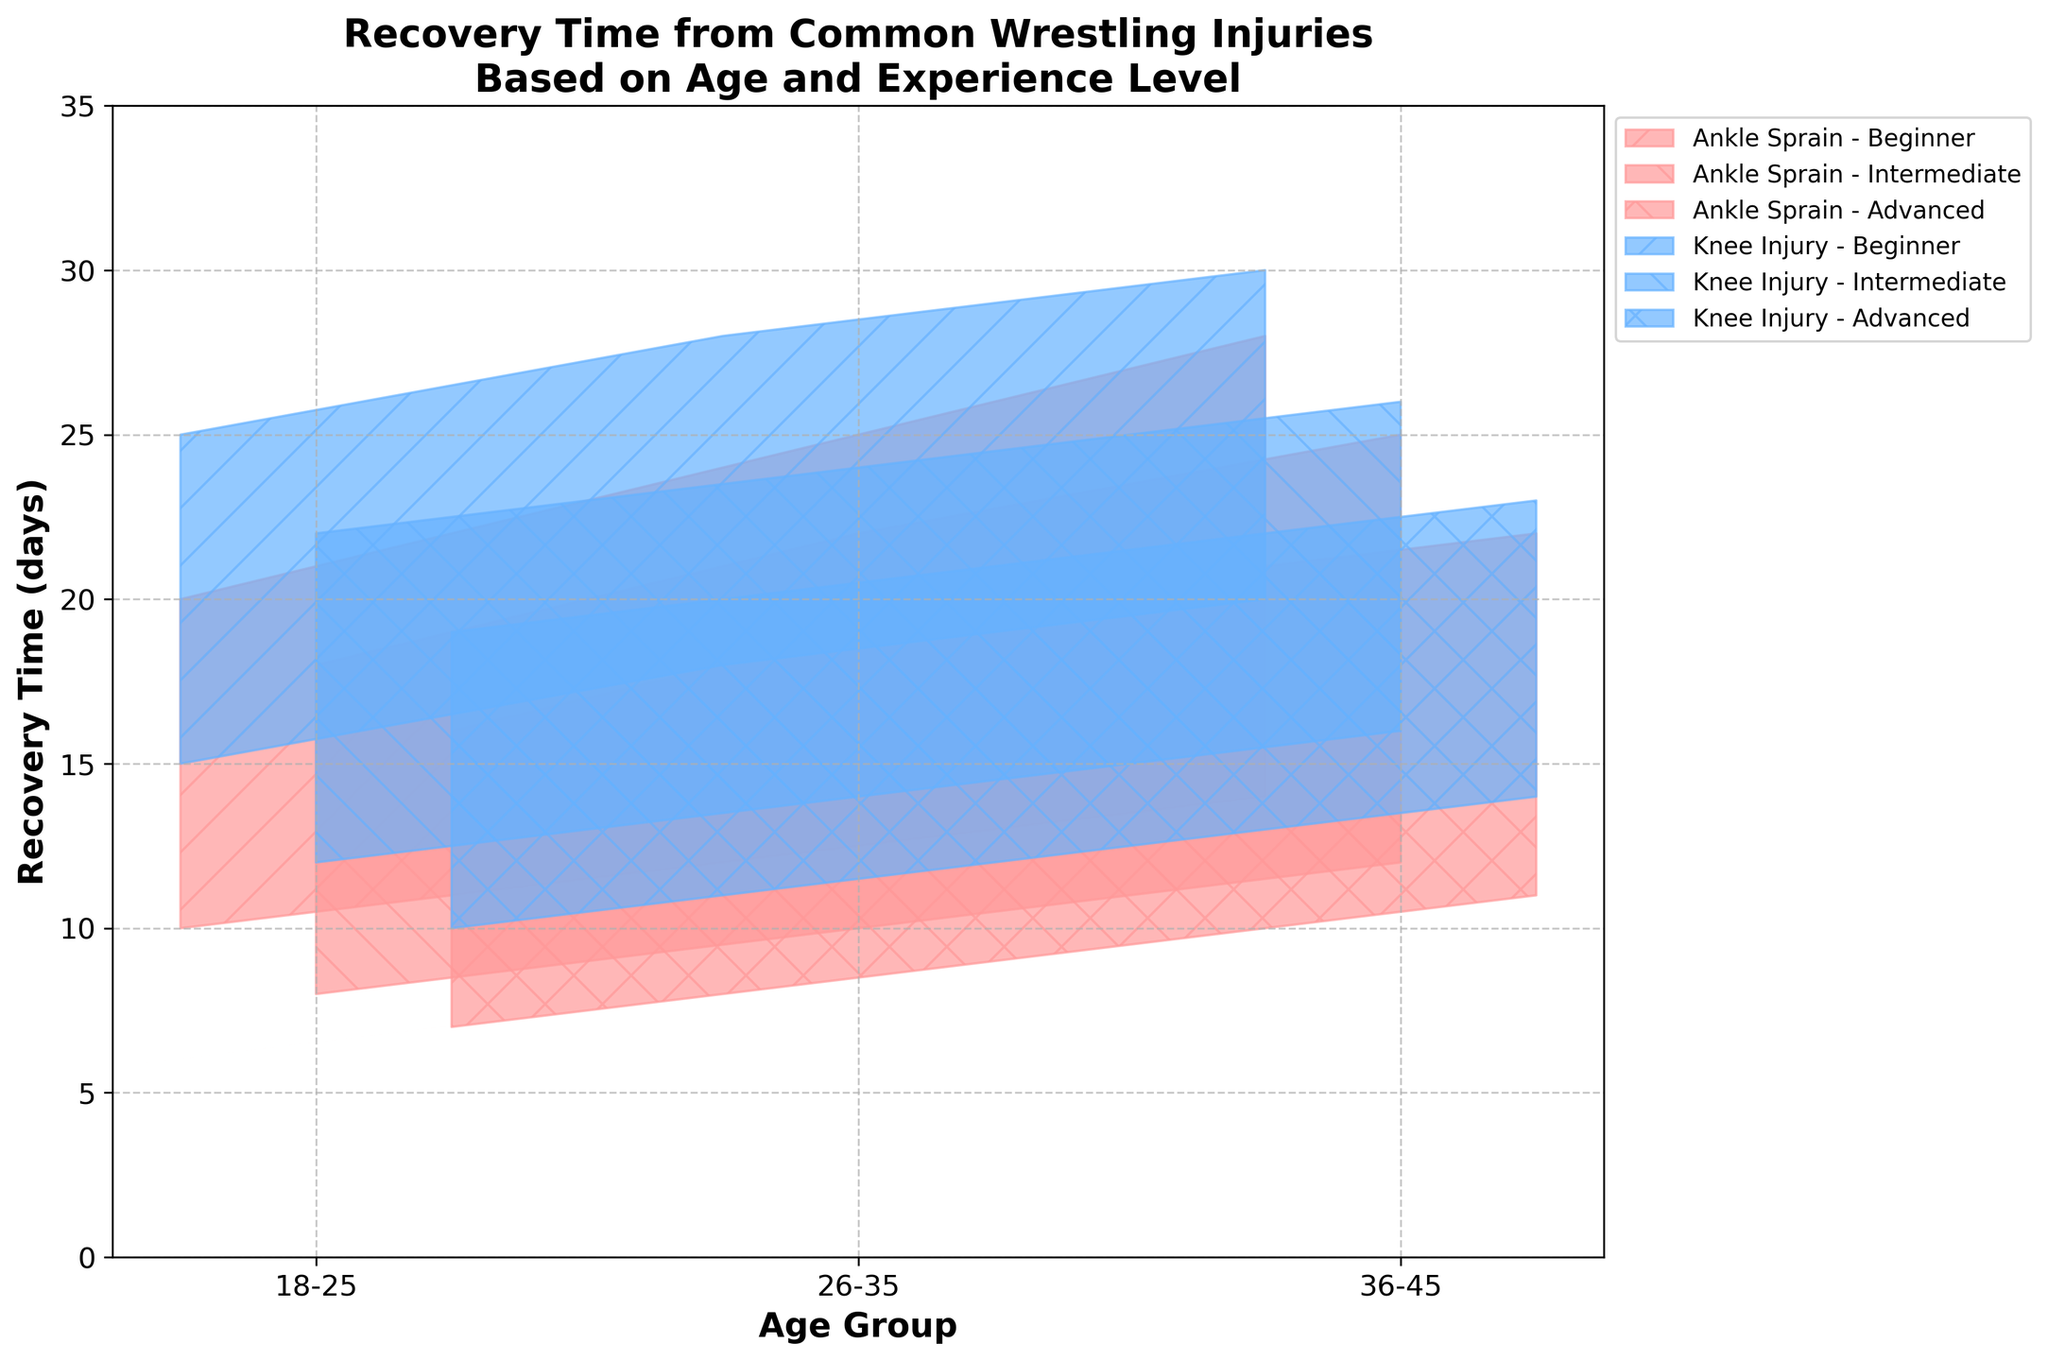What are the minimum and maximum recovery times for an ankle sprain in the 18-25 age group for beginners? The minimum recovery time for an ankle sprain in the 18-25 age group for beginners is 10 days, and the maximum recovery time is 20 days as indicated by the range in the plot for that age group and experience level.
Answer: 10 days (min), 20 days (max) Which injury in the 26-35 age group for advanced wrestlers has a shorter maximum recovery time, ankle sprain or knee injury? To determine which injury has a shorter maximum recovery time, compare the maximum values for both injuries. The maximum recovery time for ankle sprain is 20 days, and for knee injury, it is 21 days. Thus, the ankle sprain has a shorter maximum recovery time.
Answer: Ankle sprain What is the range of recovery times for knee injuries in the 36-45 age group for intermediate wrestlers? The range of recovery times can be calculated by looking at the minimum and maximum values provided. The minimum recovery time is 16 days, and the maximum recovery time is 26 days. Therefore, the range is 26 - 16 = 10 days.
Answer: 10 days How does the recovery time for ankle sprain in 18-25 age intermediate wrestlers compare to beginners in the same age group? By examining the plot, the minimum and maximum recovery times for intermediate wrestlers (8 and 18 days) are less than those for beginner wrestlers (10 and 20 days). Therefore, recovery times for intermediates are generally shorter.
Answer: Shorter for intermediate wrestlers Among all groups, which combination of age and experience has the shortest minimum recovery time for knee injuries? Review the minimum recovery times for knee injuries across all combinations of age and experience. The 18-25 age group advanced wrestlers have the shortest minimum recovery time of 10 days.
Answer: 18-25 Advanced 